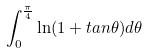<formula> <loc_0><loc_0><loc_500><loc_500>\int _ { 0 } ^ { \frac { \pi } { 4 } } \ln ( 1 + t a n \theta ) d \theta</formula> 